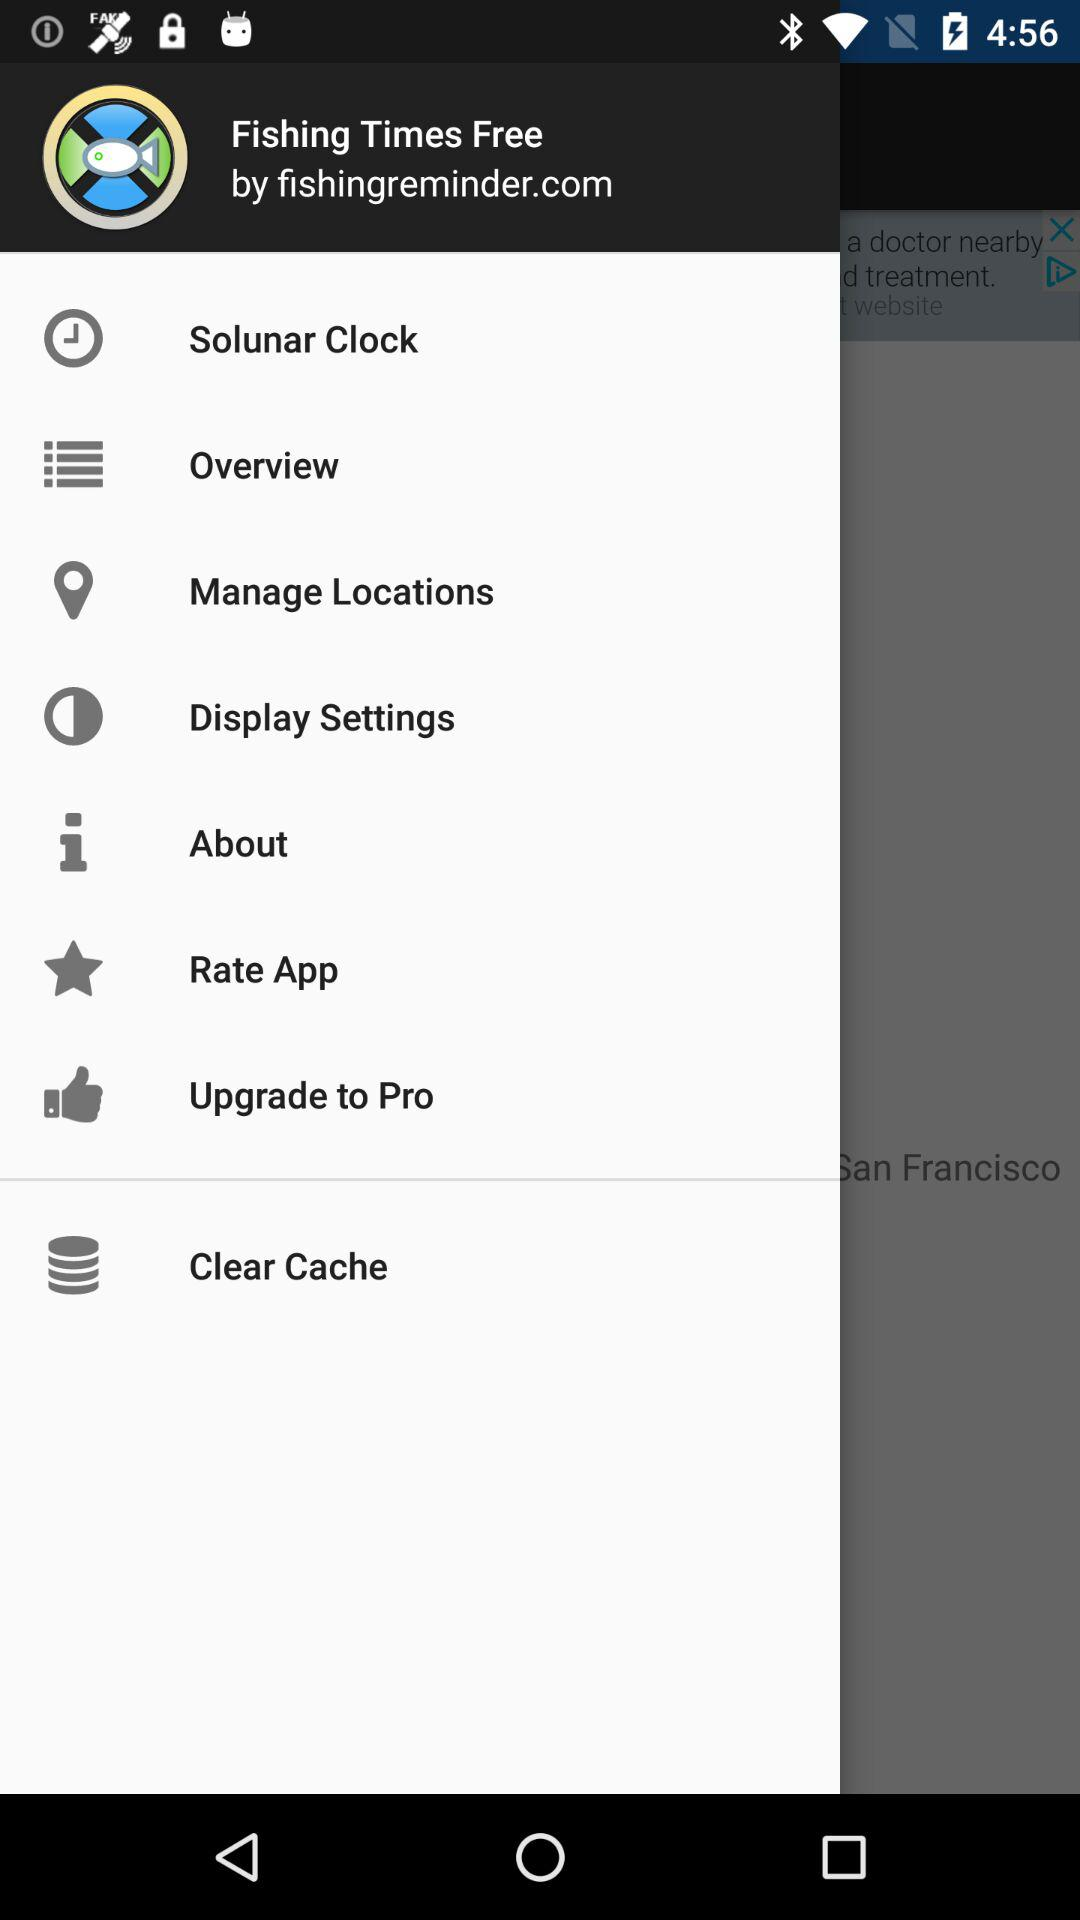What is the application name? The application name is "Fishing Times Free". 